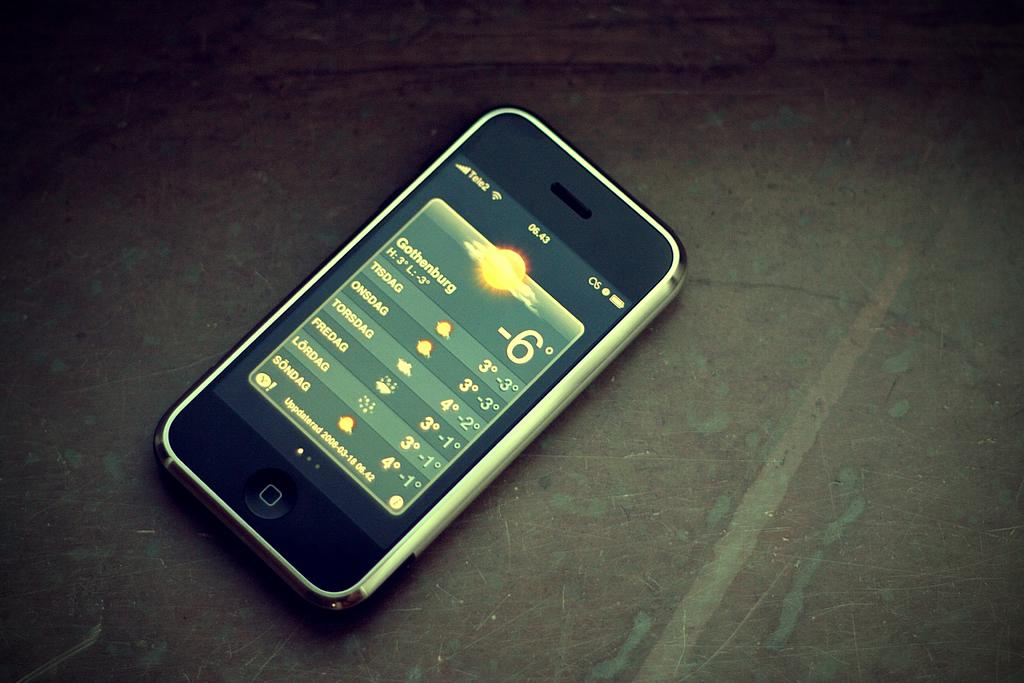Provide a one-sentence caption for the provided image. An iPhone opened up to the weather app where it is currently -6 in Gothenburg. 